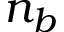Convert formula to latex. <formula><loc_0><loc_0><loc_500><loc_500>n _ { b }</formula> 